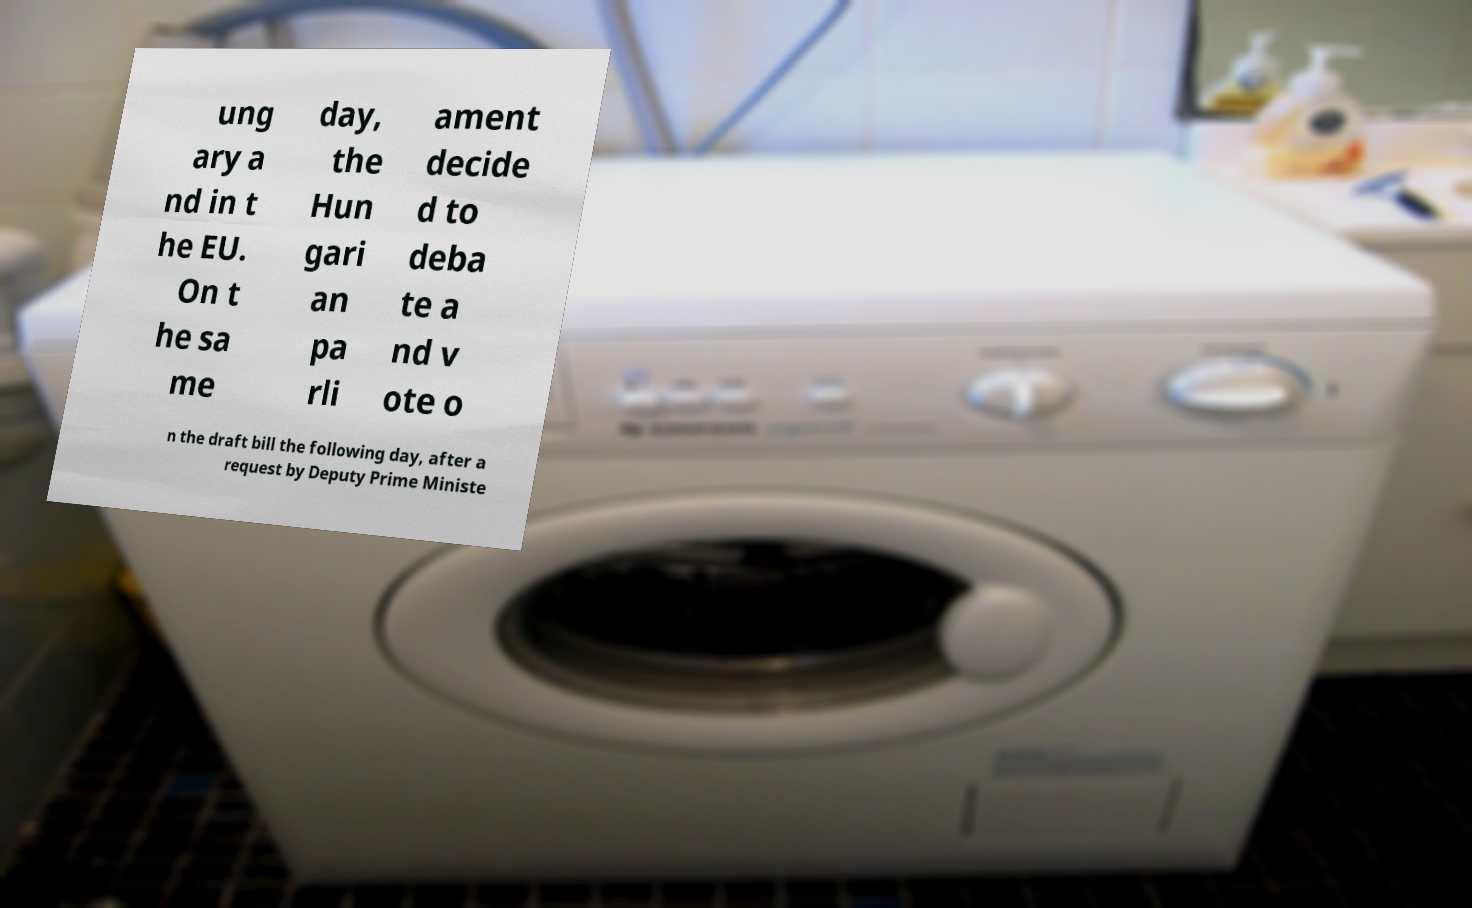Please identify and transcribe the text found in this image. ung ary a nd in t he EU. On t he sa me day, the Hun gari an pa rli ament decide d to deba te a nd v ote o n the draft bill the following day, after a request by Deputy Prime Ministe 